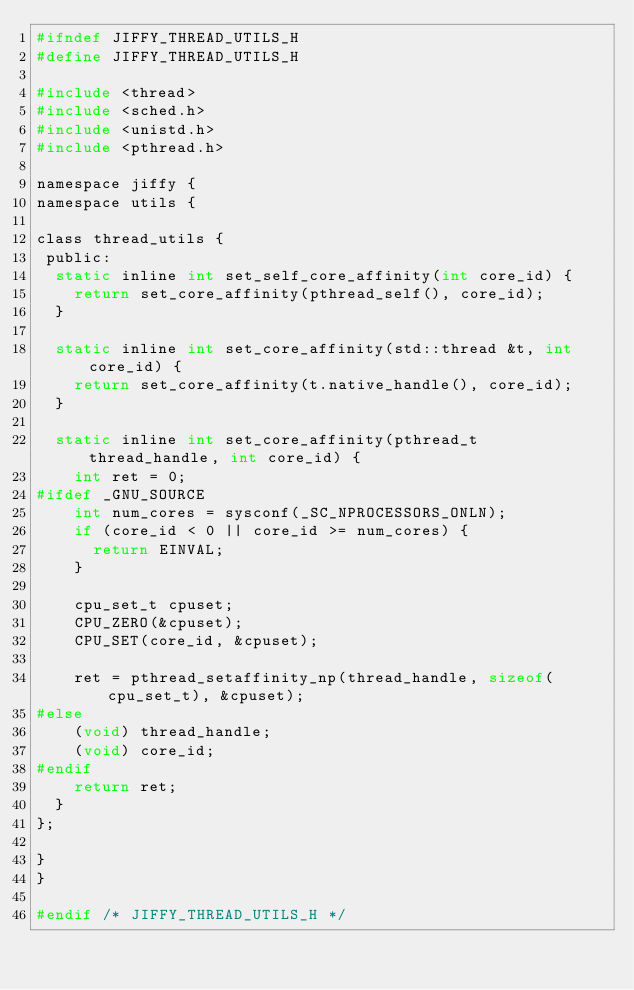Convert code to text. <code><loc_0><loc_0><loc_500><loc_500><_C_>#ifndef JIFFY_THREAD_UTILS_H
#define JIFFY_THREAD_UTILS_H

#include <thread>
#include <sched.h>
#include <unistd.h>
#include <pthread.h>

namespace jiffy {
namespace utils {

class thread_utils {
 public:
  static inline int set_self_core_affinity(int core_id) {
    return set_core_affinity(pthread_self(), core_id);
  }

  static inline int set_core_affinity(std::thread &t, int core_id) {
    return set_core_affinity(t.native_handle(), core_id);
  }

  static inline int set_core_affinity(pthread_t thread_handle, int core_id) {
    int ret = 0;
#ifdef _GNU_SOURCE
    int num_cores = sysconf(_SC_NPROCESSORS_ONLN);
    if (core_id < 0 || core_id >= num_cores) {
      return EINVAL;
    }

    cpu_set_t cpuset;
    CPU_ZERO(&cpuset);
    CPU_SET(core_id, &cpuset);

    ret = pthread_setaffinity_np(thread_handle, sizeof(cpu_set_t), &cpuset);
#else
    (void) thread_handle;
    (void) core_id;
#endif
    return ret;
  }
};

}
}

#endif /* JIFFY_THREAD_UTILS_H */</code> 